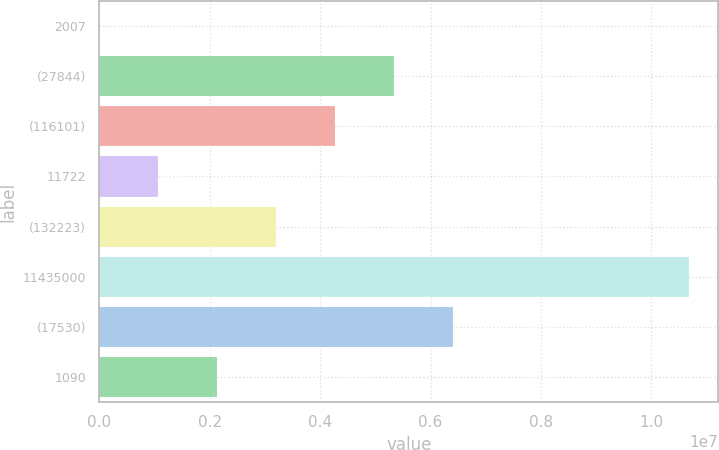<chart> <loc_0><loc_0><loc_500><loc_500><bar_chart><fcel>2007<fcel>(27844)<fcel>(116101)<fcel>11722<fcel>(132223)<fcel>11435000<fcel>(17530)<fcel>1090<nl><fcel>2006<fcel>5.3385e+06<fcel>4.2712e+06<fcel>1.06931e+06<fcel>3.2039e+06<fcel>1.0675e+07<fcel>6.4058e+06<fcel>2.1366e+06<nl></chart> 